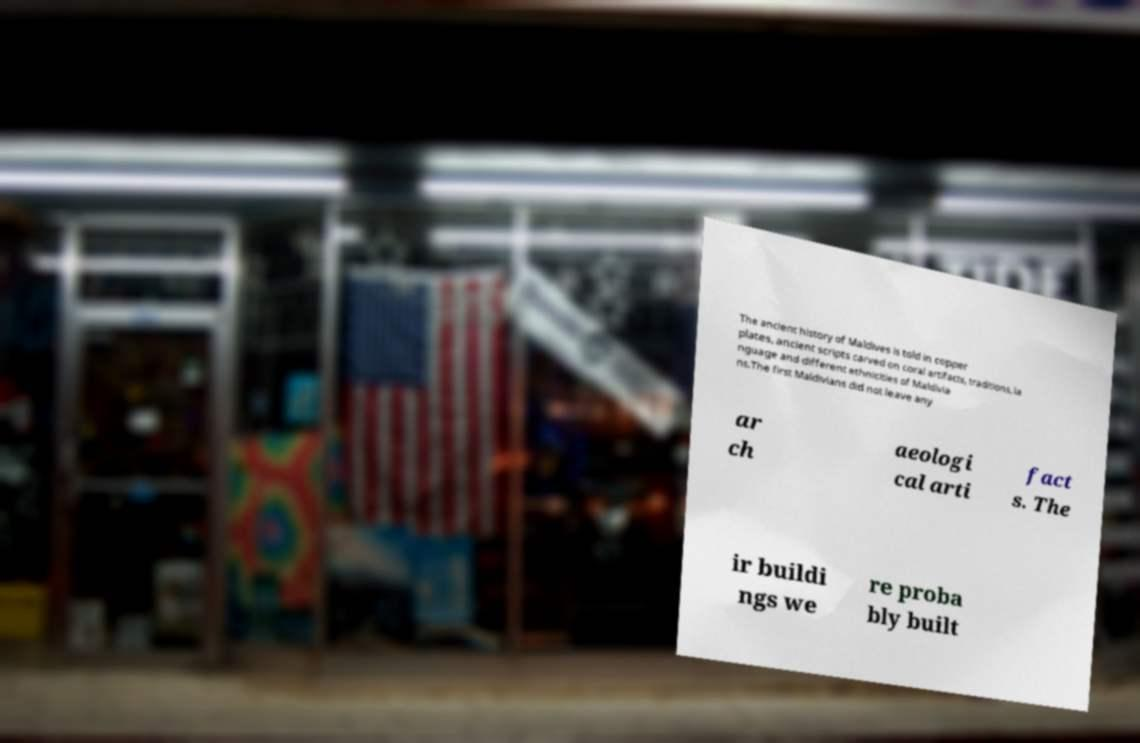Please read and relay the text visible in this image. What does it say? The ancient history of Maldives is told in copper plates, ancient scripts carved on coral artifacts, traditions, la nguage and different ethnicities of Maldivia ns.The first Maldivians did not leave any ar ch aeologi cal arti fact s. The ir buildi ngs we re proba bly built 